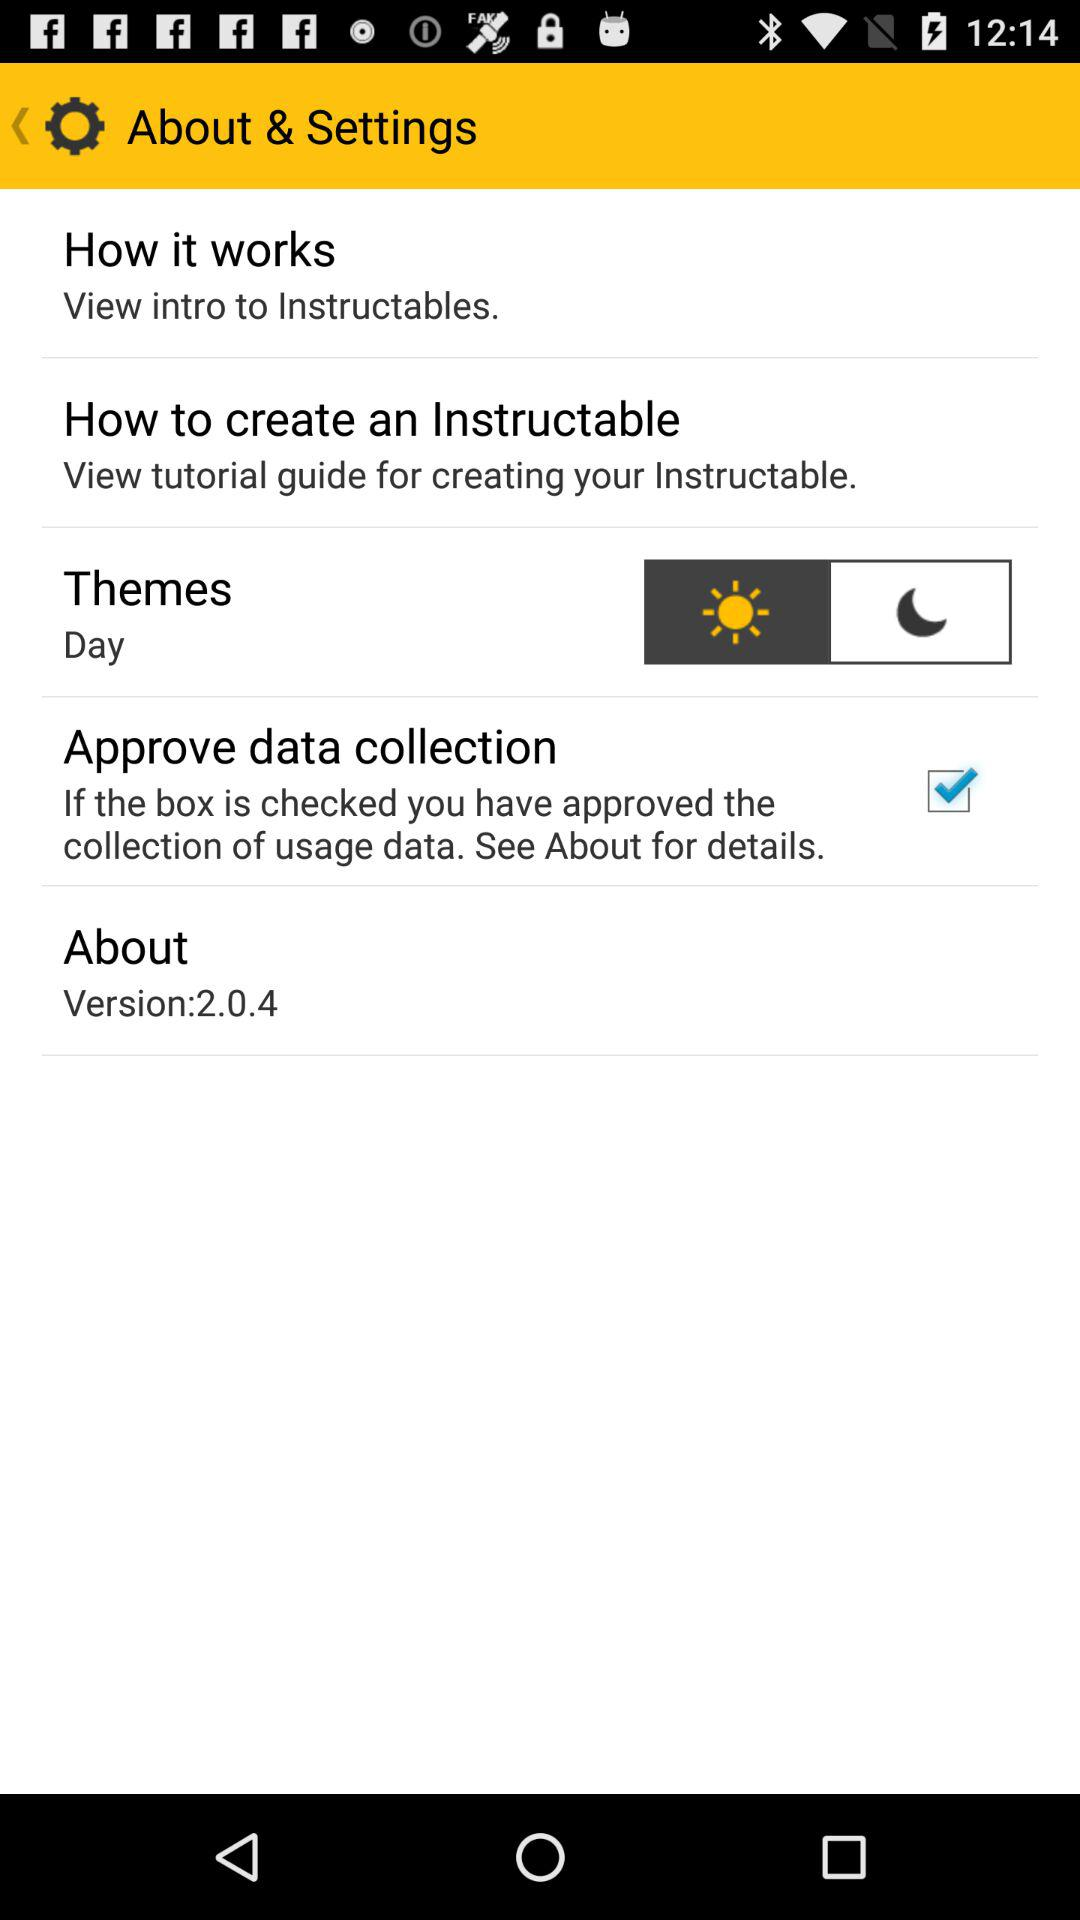Which theme has been selected? The selected theme is "Day". 